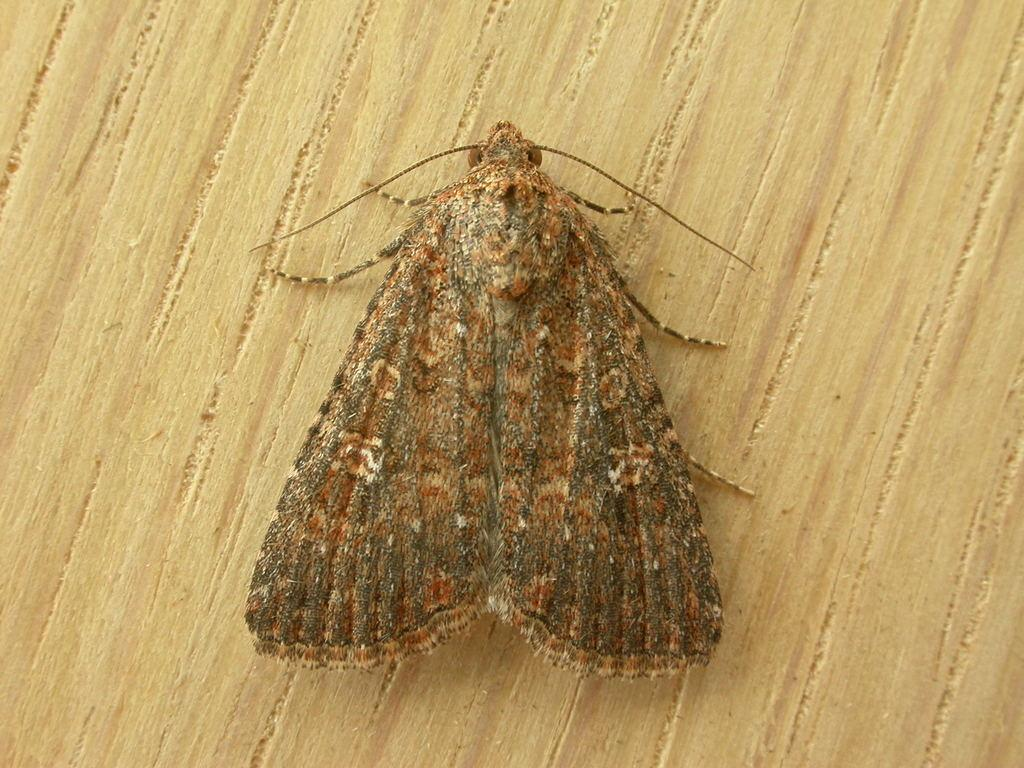What type of creature is present in the image? There is an insect in the image. Where is the insect located? The insect is on a table. What type of marble is the insect playing with on the table? There is no marble present in the image; the insect is simply located on the table. How many babies are visible in the image? There are no babies present in the image. 